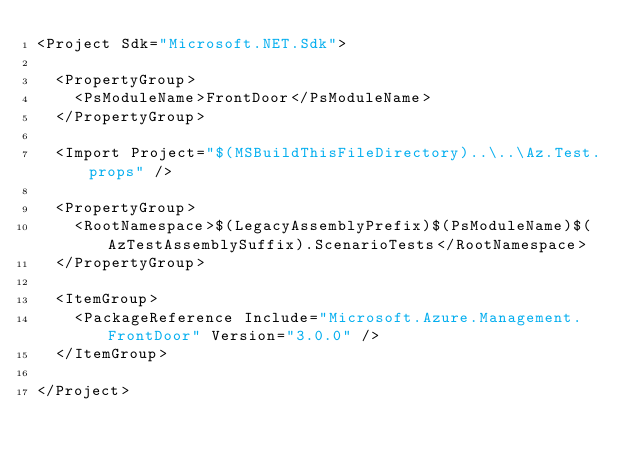<code> <loc_0><loc_0><loc_500><loc_500><_XML_><Project Sdk="Microsoft.NET.Sdk">

  <PropertyGroup>
    <PsModuleName>FrontDoor</PsModuleName>
  </PropertyGroup>

  <Import Project="$(MSBuildThisFileDirectory)..\..\Az.Test.props" />

  <PropertyGroup>
    <RootNamespace>$(LegacyAssemblyPrefix)$(PsModuleName)$(AzTestAssemblySuffix).ScenarioTests</RootNamespace>
  </PropertyGroup>

  <ItemGroup>
    <PackageReference Include="Microsoft.Azure.Management.FrontDoor" Version="3.0.0" />
  </ItemGroup>

</Project></code> 